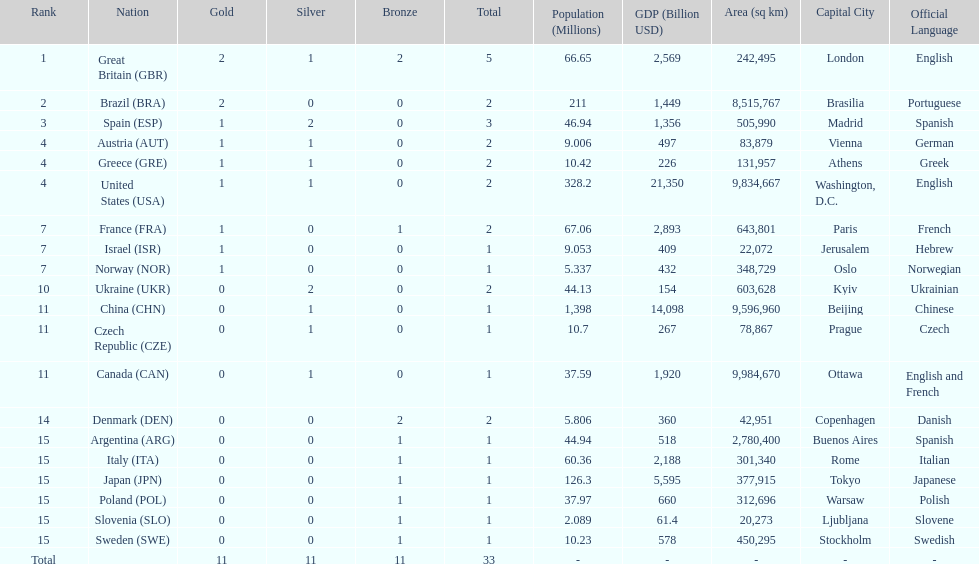Who won more gold medals than spain? Great Britain (GBR), Brazil (BRA). Help me parse the entirety of this table. {'header': ['Rank', 'Nation', 'Gold', 'Silver', 'Bronze', 'Total', 'Population (Millions)', 'GDP (Billion USD)', 'Area (sq km)', 'Capital City', 'Official Language'], 'rows': [['1', 'Great Britain\xa0(GBR)', '2', '1', '2', '5', '66.65', '2,569', '242,495', 'London', 'English'], ['2', 'Brazil\xa0(BRA)', '2', '0', '0', '2', '211', '1,449', '8,515,767', 'Brasilia', 'Portuguese'], ['3', 'Spain\xa0(ESP)', '1', '2', '0', '3', '46.94', '1,356', '505,990', 'Madrid', 'Spanish'], ['4', 'Austria\xa0(AUT)', '1', '1', '0', '2', '9.006', '497', '83,879', 'Vienna', 'German'], ['4', 'Greece\xa0(GRE)', '1', '1', '0', '2', '10.42', '226', '131,957', 'Athens', 'Greek'], ['4', 'United States\xa0(USA)', '1', '1', '0', '2', '328.2', '21,350', '9,834,667', 'Washington, D.C.', 'English'], ['7', 'France\xa0(FRA)', '1', '0', '1', '2', '67.06', '2,893', '643,801', 'Paris', 'French'], ['7', 'Israel\xa0(ISR)', '1', '0', '0', '1', '9.053', '409', '22,072', 'Jerusalem', 'Hebrew'], ['7', 'Norway\xa0(NOR)', '1', '0', '0', '1', '5.337', '432', '348,729', 'Oslo', 'Norwegian'], ['10', 'Ukraine\xa0(UKR)', '0', '2', '0', '2', '44.13', '154', '603,628', 'Kyiv', 'Ukrainian'], ['11', 'China\xa0(CHN)', '0', '1', '0', '1', '1,398', '14,098', '9,596,960', 'Beijing', 'Chinese'], ['11', 'Czech Republic\xa0(CZE)', '0', '1', '0', '1', '10.7', '267', '78,867', 'Prague', 'Czech'], ['11', 'Canada\xa0(CAN)', '0', '1', '0', '1', '37.59', '1,920', '9,984,670', 'Ottawa', 'English and French'], ['14', 'Denmark\xa0(DEN)', '0', '0', '2', '2', '5.806', '360', '42,951', 'Copenhagen', 'Danish'], ['15', 'Argentina\xa0(ARG)', '0', '0', '1', '1', '44.94', '518', '2,780,400', 'Buenos Aires', 'Spanish'], ['15', 'Italy\xa0(ITA)', '0', '0', '1', '1', '60.36', '2,188', '301,340', 'Rome', 'Italian'], ['15', 'Japan\xa0(JPN)', '0', '0', '1', '1', '126.3', '5,595', '377,915', 'Tokyo', 'Japanese'], ['15', 'Poland\xa0(POL)', '0', '0', '1', '1', '37.97', '660', '312,696', 'Warsaw', 'Polish'], ['15', 'Slovenia\xa0(SLO)', '0', '0', '1', '1', '2.089', '61.4', '20,273', 'Ljubljana', 'Slovene'], ['15', 'Sweden\xa0(SWE)', '0', '0', '1', '1', '10.23', '578', '450,295', 'Stockholm', 'Swedish'], ['Total', '', '11', '11', '11', '33', '-', '-', '-', '-', '-']]} 